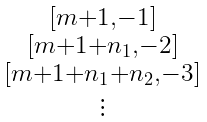<formula> <loc_0><loc_0><loc_500><loc_500>\begin{smallmatrix} [ m + 1 , - 1 ] \\ [ m + 1 + n _ { 1 } , - 2 ] \\ [ m + 1 + n _ { 1 } + n _ { 2 } , - 3 ] \\ \vdots \end{smallmatrix}</formula> 